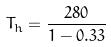<formula> <loc_0><loc_0><loc_500><loc_500>T _ { h } = \frac { 2 8 0 } { 1 - 0 . 3 3 }</formula> 